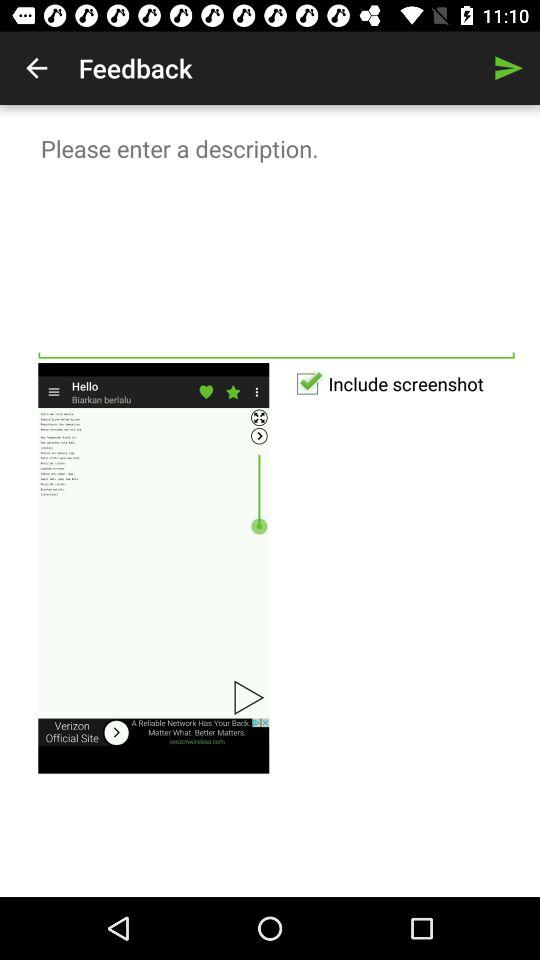What is the status of "Include screenshot"? The status is "on". 